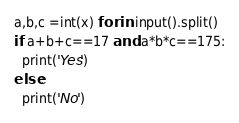<code> <loc_0><loc_0><loc_500><loc_500><_Python_>a,b,c =int(x) for in input().split()
if a+b+c==17 and a*b*c==175:
  print('Yes')
else:
  print('No')</code> 